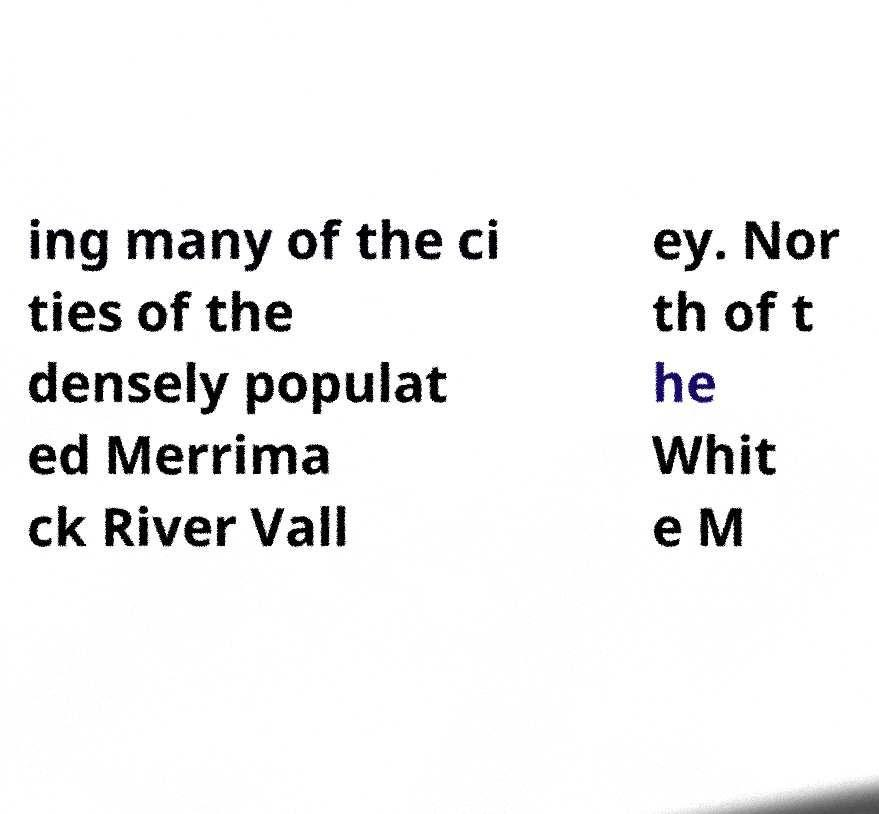Please read and relay the text visible in this image. What does it say? ing many of the ci ties of the densely populat ed Merrima ck River Vall ey. Nor th of t he Whit e M 